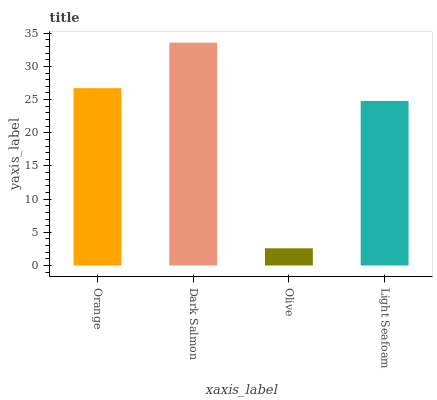Is Olive the minimum?
Answer yes or no. Yes. Is Dark Salmon the maximum?
Answer yes or no. Yes. Is Dark Salmon the minimum?
Answer yes or no. No. Is Olive the maximum?
Answer yes or no. No. Is Dark Salmon greater than Olive?
Answer yes or no. Yes. Is Olive less than Dark Salmon?
Answer yes or no. Yes. Is Olive greater than Dark Salmon?
Answer yes or no. No. Is Dark Salmon less than Olive?
Answer yes or no. No. Is Orange the high median?
Answer yes or no. Yes. Is Light Seafoam the low median?
Answer yes or no. Yes. Is Dark Salmon the high median?
Answer yes or no. No. Is Olive the low median?
Answer yes or no. No. 